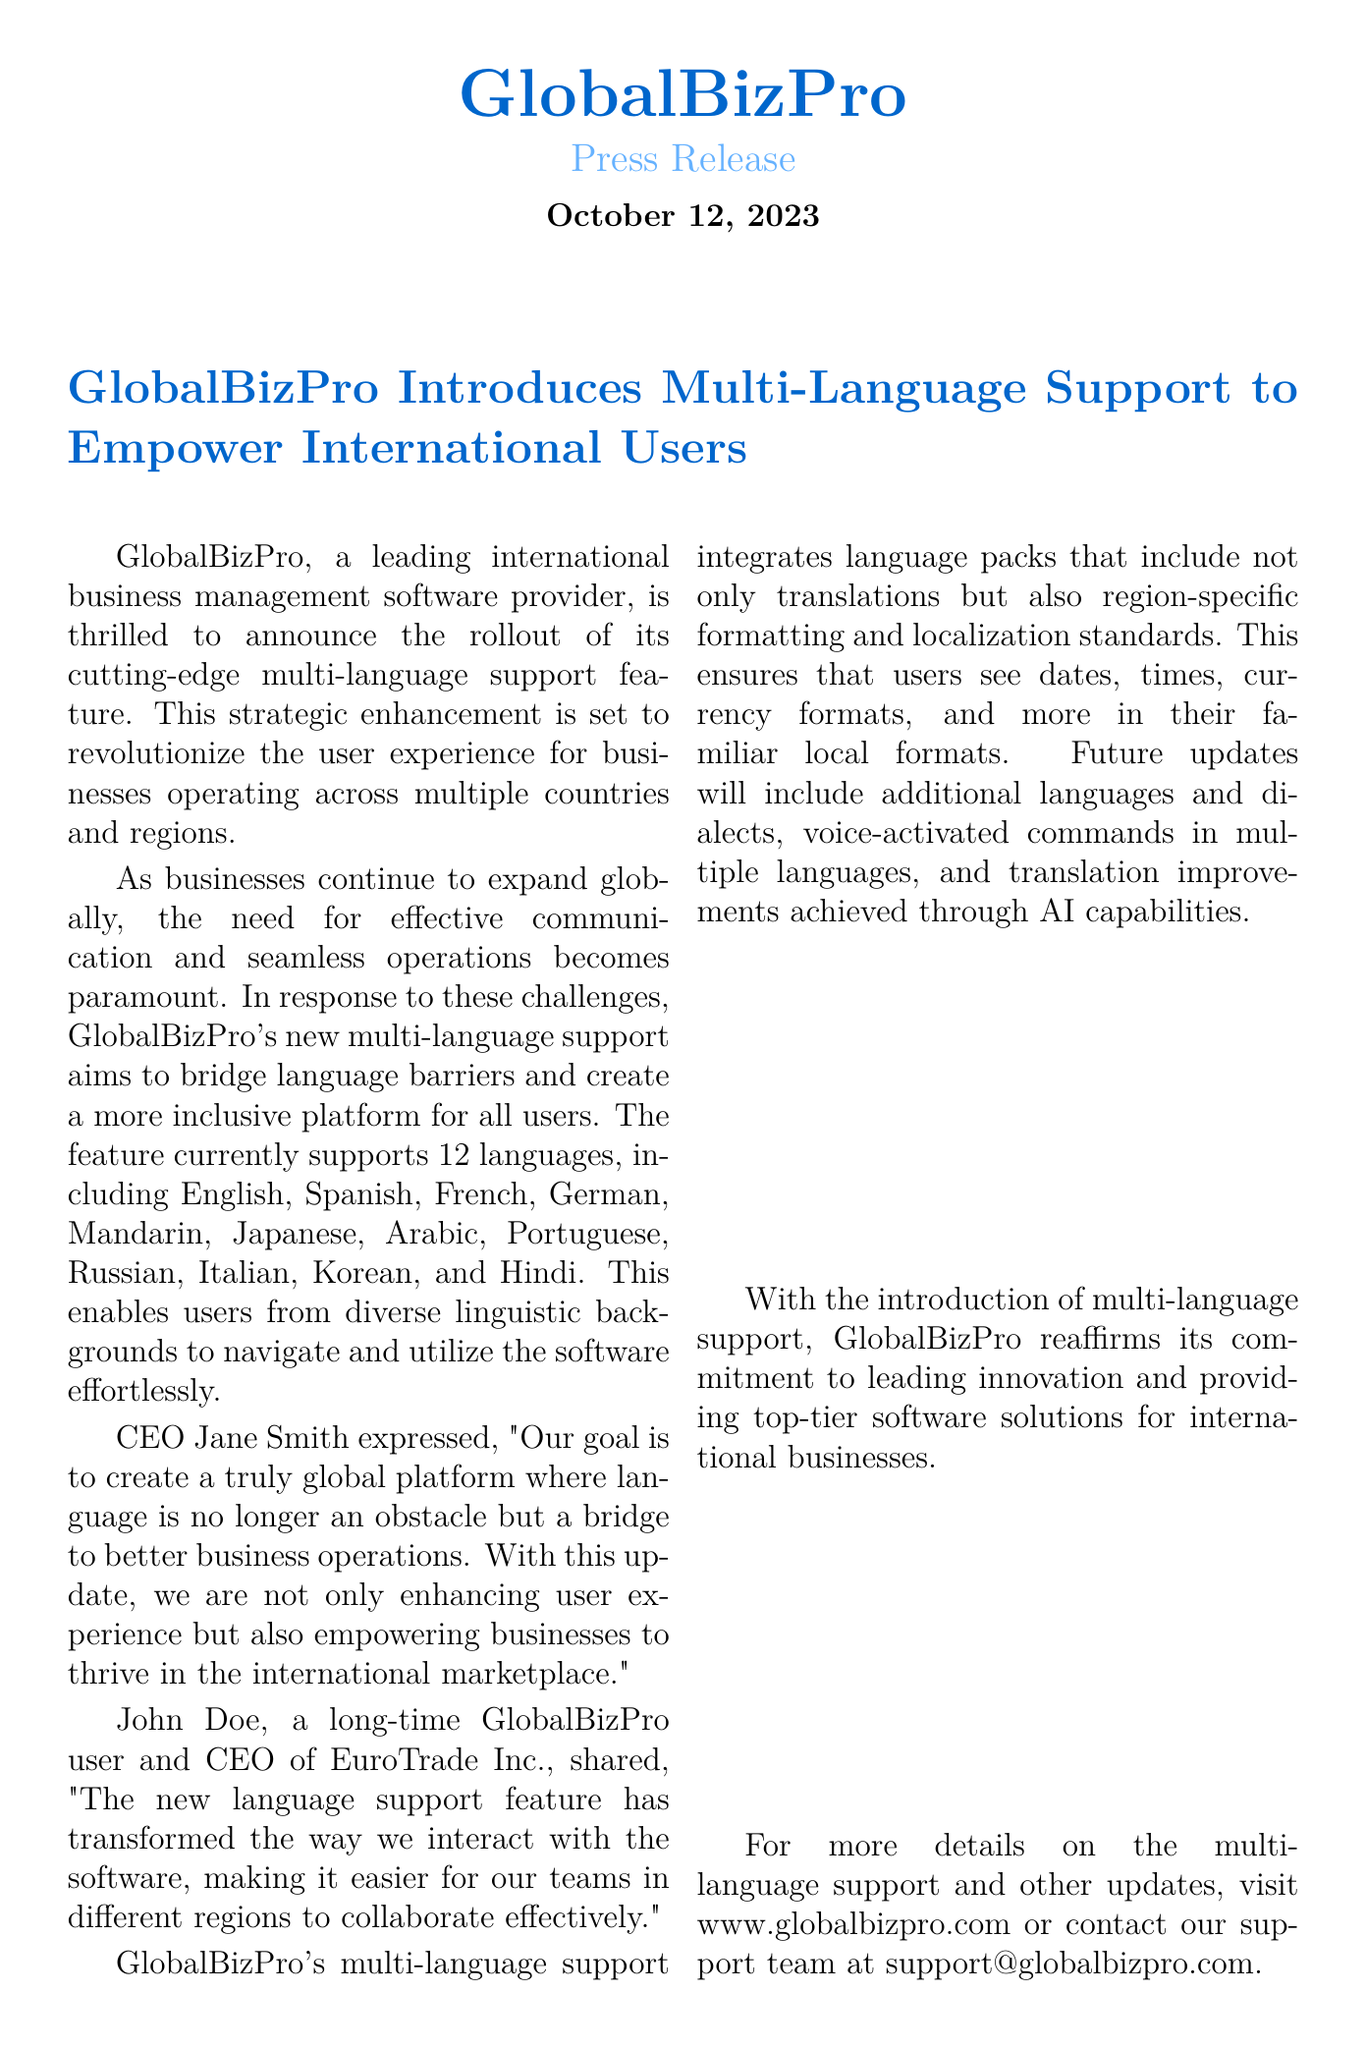What is the date of the press release? The date of the press release is included in the document header.
Answer: October 12, 2023 Who is the CEO of GlobalBizPro? The CEO's name is mentioned in the document along with their quote.
Answer: Jane Smith How many languages does the multi-language support feature currently support? The document specifies the number of languages supported in the feature description.
Answer: 12 languages What company does John Doe represent? John Doe's affiliation is mentioned in the quote provided in the release.
Answer: EuroTrade Inc What is the primary purpose of the new multi-language support? The purpose is highlighted in the introduction paragraph, focusing on enhancing communication.
Answer: To empower international users What additional features are mentioned for future updates? The future updates section discusses enhancements to the existing multi-language support.
Answer: Voice-activated commands What is the contact email for GlobalBizPro? The contact email is provided at the end of the press release.
Answer: press@globalbizpro.com What is the main color defined in the document? The document mentions a specific color used in the title format.
Answer: RGB(0,102,204) What location is GlobalBizPro based in? The specific address is provided in the contact information section.
Answer: 1 Market St, San Francisco, CA 94103 